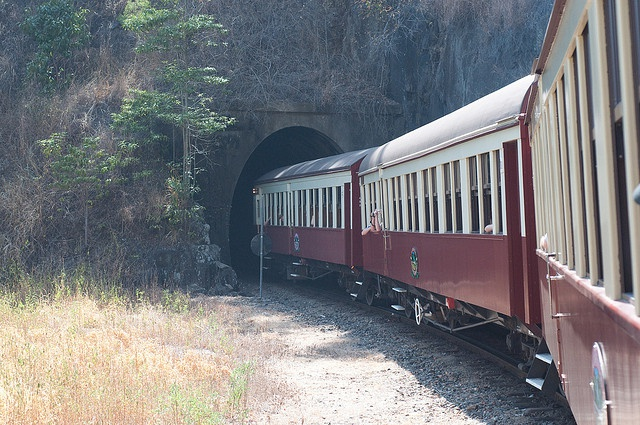Describe the objects in this image and their specific colors. I can see train in gray, darkgray, lightgray, and black tones, people in gray, darkgray, and lightgray tones, people in gray, darkgray, lightgray, and pink tones, people in gray, lightgray, lightpink, and darkgray tones, and people in gray, darkgray, and lightpink tones in this image. 